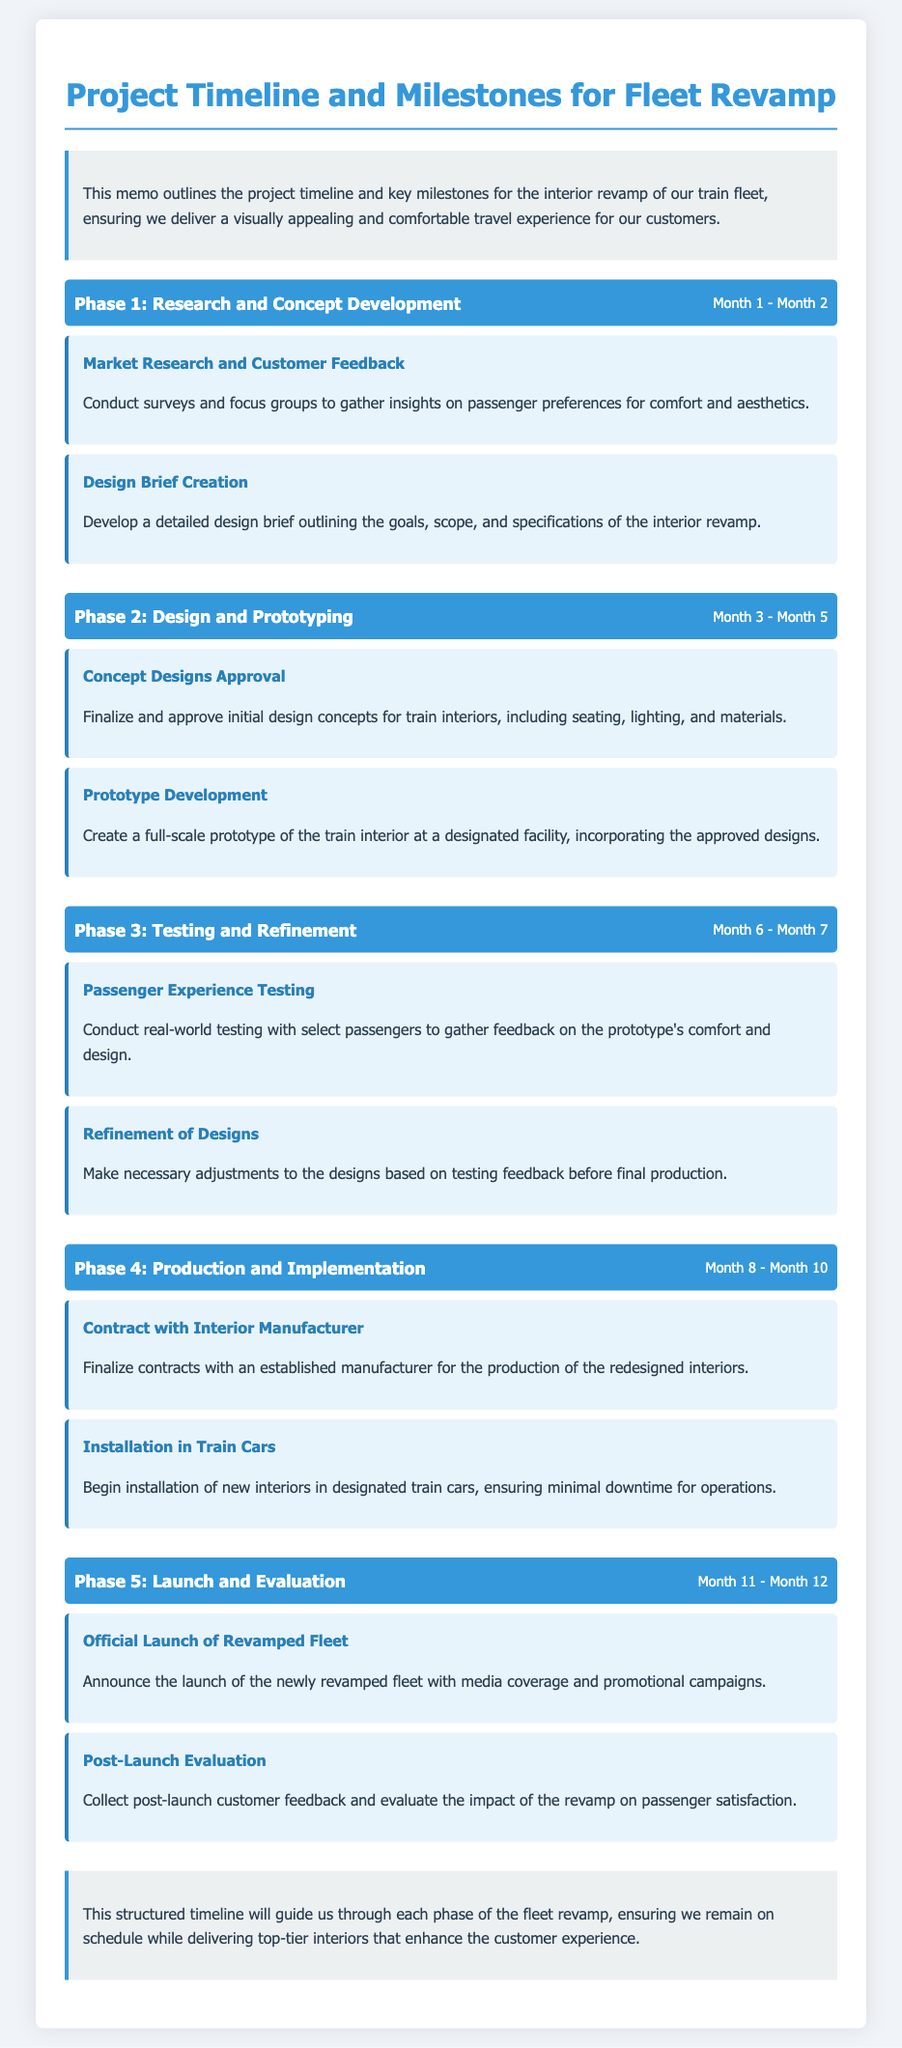What is the duration of Phase 1? Phase 1 lasts from Month 1 to Month 2 as stated in the document.
Answer: Month 1 - Month 2 What is the first milestone in Phase 2? The first milestone in Phase 2 is mentioned as "Concept Designs Approval".
Answer: Concept Designs Approval How many phases are outlined in the memo? The document lists a total of five phases for the fleet revamp project.
Answer: Five What is the focus of the final phase? The final phase focuses on the launch and evaluation of the revamped fleet as specified in the document.
Answer: Launch and Evaluation What type of research is conducted in Phase 1? The type of research conducted in Phase 1 involves market research and customer feedback.
Answer: Market Research and Customer Feedback What key aspect is being tested in Phase 3? In Phase 3, the passenger experience is being tested with select passengers for feedback.
Answer: Passenger Experience Testing Which phase includes prototype development? Prototype development occurs in Phase 2 as outlined in the memo.
Answer: Phase 2 What does the post-launch evaluation entail? The post-launch evaluation involves collecting customer feedback and evaluating impact on satisfaction.
Answer: Customer feedback and evaluating impact on satisfaction 